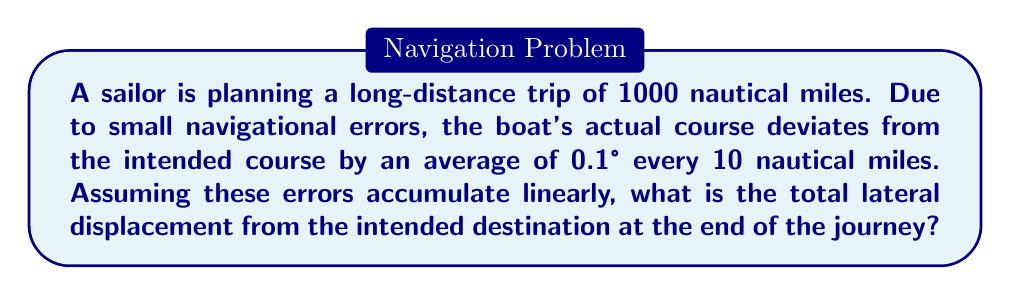Solve this math problem. Let's approach this step-by-step:

1) First, we need to calculate how many 10-mile segments are in the 1000-mile journey:
   $\frac{1000 \text{ miles}}{10 \text{ miles/segment}} = 100 \text{ segments}$

2) The angular deviation per segment is 0.1°. Over 100 segments, the total angular deviation is:
   $100 \times 0.1° = 10°$

3) Now, we can treat this as a right triangle problem. The hypotenuse is the 1000-mile journey, and we need to find the opposite side (lateral displacement).

4) We can use the tangent function:
   $\tan(\theta) = \frac{\text{opposite}}{\text{adjacent}}$

5) In our case:
   $\tan(10°) = \frac{\text{lateral displacement}}{1000 \text{ miles}}$

6) Solving for lateral displacement:
   $\text{lateral displacement} = 1000 \times \tan(10°)$

7) Using a calculator or trigonometric tables:
   $\text{lateral displacement} = 1000 \times 0.17632698 \approx 176.33 \text{ nautical miles}$

Therefore, the total lateral displacement at the end of the journey is approximately 176.33 nautical miles.
Answer: 176.33 nautical miles 